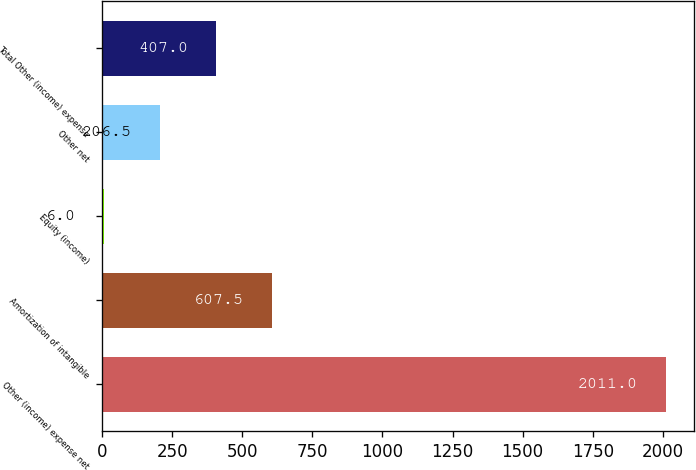<chart> <loc_0><loc_0><loc_500><loc_500><bar_chart><fcel>Other (income) expense net<fcel>Amortization of intangible<fcel>Equity (income)<fcel>Other net<fcel>Total Other (income) expense<nl><fcel>2011<fcel>607.5<fcel>6<fcel>206.5<fcel>407<nl></chart> 